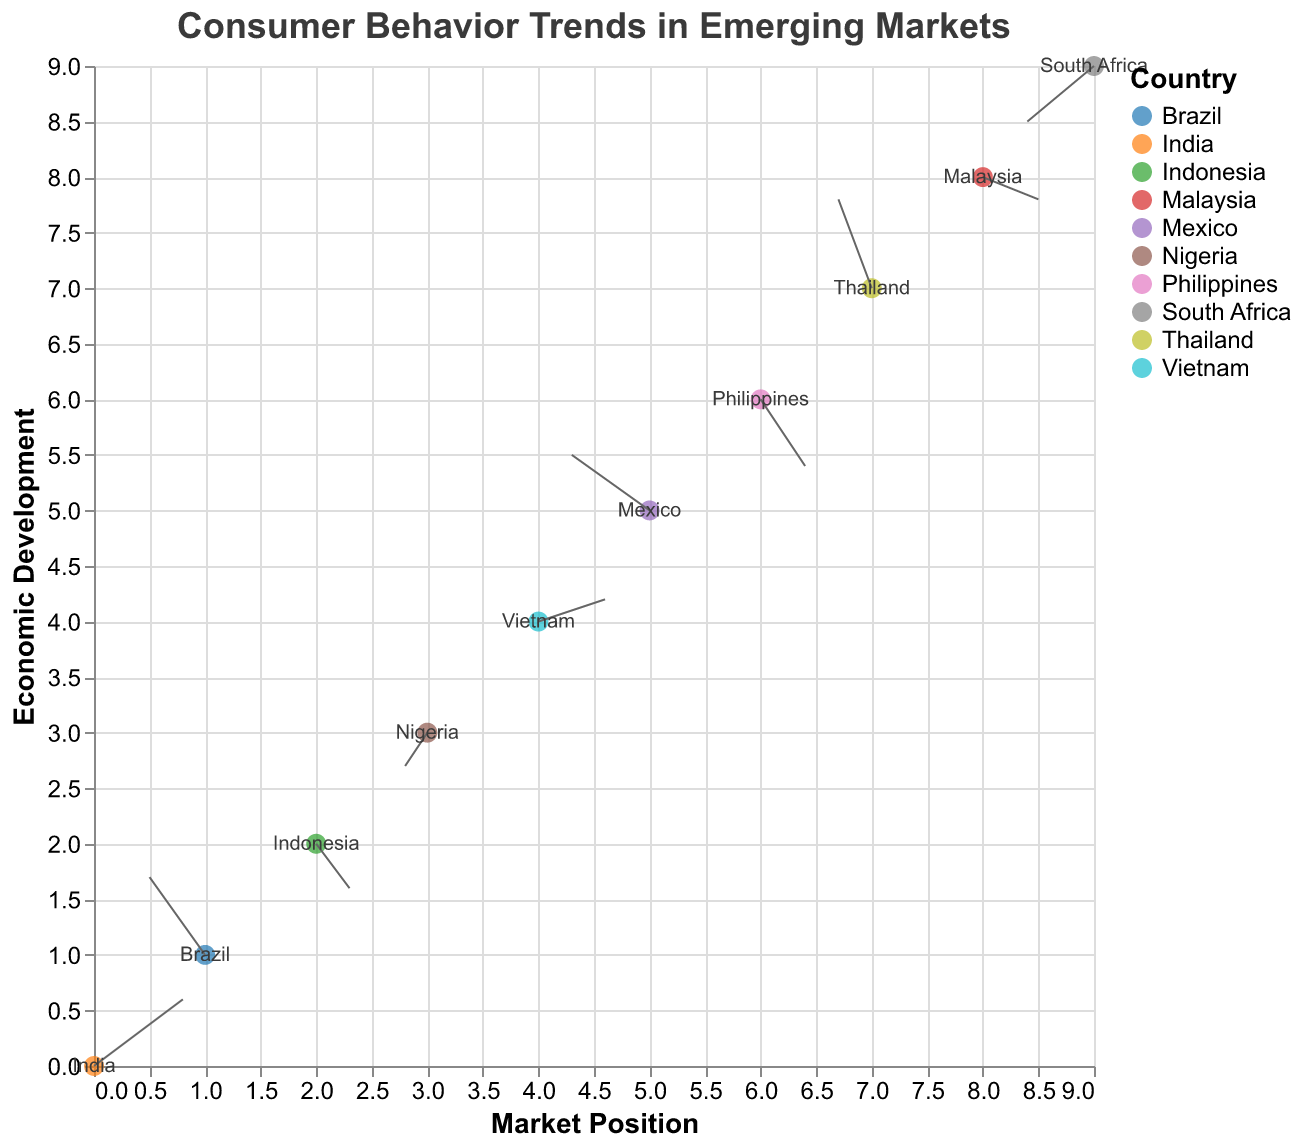Which country shows the strongest positive change in consumer behavior? To identify the strongest positive change, we compare the lengths of the arrows. The length of the arrow is determined by the direction vectors (u, v). India has the largest positive change with u=0.8 and v=0.6, giving a vector length of sqrt(0.8^2 + 0.6^2) = 1.
Answer: India What is the title of the plot? The title of the plot is found at the top of the chart. It is given as "Consumer Behavior Trends in Emerging Markets."
Answer: Consumer Behavior Trends in Emerging Markets Which country shows a negative change in both market position and economic development? We are looking for a data point where both u and v are negative. Nigeria has u=-0.2 and v=-0.3, and South Africa has u=-0.6 and v=-0.5. So, both Nigeria and South Africa show negative changes in both directions.
Answer: Nigeria and South Africa How many countries are represented in the plot? By counting the unique categories within the "Country" field, we can determine the number of countries. There are 10 data points, each representing a different country.
Answer: 10 Which country has the largest positive change in economic development (y direction)? To find this, compare the "v" values of each country. Thailand has the highest v value at 0.8.
Answer: Thailand Which country shows a positive change in market position but a negative change in economic development? We need to look for a country where u > 0 and v < 0. Indonesia and Philippines have such changes: Indonesia (u=0.3, v=-0.4) and Philippines (u=0.4, v=-0.6).
Answer: Indonesia and Philippines How does the consumer behavior trend in Brazil compare to that in Mexico? Brazil has u=-0.5, v=0.7, and Mexico has u=-0.7, v=0.5. Brazil shows a stronger positive change in economic development than Mexico but a slight negative change in the market position, while Mexico also shows a negative change in market position. The vector length for Brazil is sqrt((-0.5)^2 + 0.7^2) = 0.86, and for Mexico, it is sqrt((-0.7)^2 + 0.5^2) = 0.86.
Answer: Brazil shows a similar overall change magnitude but in a different direction than Mexico Which countries show an improvement in market position? A positive change in market position means u > 0. The countries that meet this criterion are India, Indonesia, Vietnam, Philippines, and Malaysia.
Answer: India, Indonesia, Vietnam, Philippines, Malaysia What is the direction of the arrow for Malaysia? From the data, Malaysia has u=0.5 and v=-0.2. The arrow for Malaysia would point to the right (positive x) and slightly downward (negative y).
Answer: Right and slightly downward 